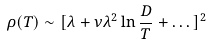Convert formula to latex. <formula><loc_0><loc_0><loc_500><loc_500>\rho ( T ) \sim [ \lambda + \nu \lambda ^ { 2 } \ln \frac { D } { T } + \dots ] ^ { 2 }</formula> 